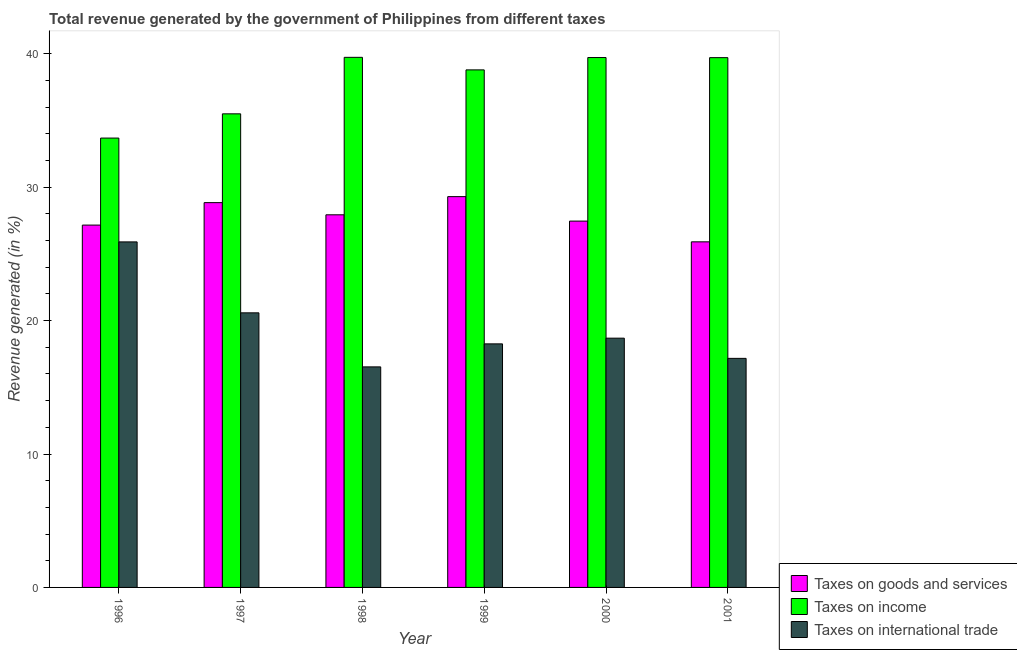How many groups of bars are there?
Your answer should be very brief. 6. Are the number of bars per tick equal to the number of legend labels?
Provide a succinct answer. Yes. Are the number of bars on each tick of the X-axis equal?
Give a very brief answer. Yes. How many bars are there on the 4th tick from the right?
Your response must be concise. 3. What is the percentage of revenue generated by taxes on income in 2001?
Offer a very short reply. 39.71. Across all years, what is the maximum percentage of revenue generated by taxes on income?
Your response must be concise. 39.74. Across all years, what is the minimum percentage of revenue generated by tax on international trade?
Give a very brief answer. 16.53. In which year was the percentage of revenue generated by taxes on goods and services maximum?
Your answer should be very brief. 1999. In which year was the percentage of revenue generated by tax on international trade minimum?
Provide a short and direct response. 1998. What is the total percentage of revenue generated by tax on international trade in the graph?
Offer a very short reply. 117.14. What is the difference between the percentage of revenue generated by tax on international trade in 1998 and that in 1999?
Offer a very short reply. -1.73. What is the difference between the percentage of revenue generated by tax on international trade in 1999 and the percentage of revenue generated by taxes on income in 2001?
Ensure brevity in your answer.  1.09. What is the average percentage of revenue generated by tax on international trade per year?
Make the answer very short. 19.52. In the year 1999, what is the difference between the percentage of revenue generated by tax on international trade and percentage of revenue generated by taxes on income?
Ensure brevity in your answer.  0. What is the ratio of the percentage of revenue generated by taxes on goods and services in 1999 to that in 2001?
Make the answer very short. 1.13. What is the difference between the highest and the second highest percentage of revenue generated by taxes on goods and services?
Your answer should be very brief. 0.45. What is the difference between the highest and the lowest percentage of revenue generated by taxes on income?
Your answer should be very brief. 6.05. Is the sum of the percentage of revenue generated by taxes on income in 1997 and 1998 greater than the maximum percentage of revenue generated by tax on international trade across all years?
Give a very brief answer. Yes. What does the 2nd bar from the left in 1998 represents?
Make the answer very short. Taxes on income. What does the 2nd bar from the right in 2000 represents?
Offer a terse response. Taxes on income. How many bars are there?
Provide a succinct answer. 18. How many years are there in the graph?
Your response must be concise. 6. Are the values on the major ticks of Y-axis written in scientific E-notation?
Offer a very short reply. No. Does the graph contain any zero values?
Make the answer very short. No. Where does the legend appear in the graph?
Give a very brief answer. Bottom right. What is the title of the graph?
Your answer should be compact. Total revenue generated by the government of Philippines from different taxes. What is the label or title of the Y-axis?
Offer a very short reply. Revenue generated (in %). What is the Revenue generated (in %) in Taxes on goods and services in 1996?
Offer a terse response. 27.16. What is the Revenue generated (in %) of Taxes on income in 1996?
Ensure brevity in your answer.  33.69. What is the Revenue generated (in %) in Taxes on international trade in 1996?
Offer a terse response. 25.9. What is the Revenue generated (in %) in Taxes on goods and services in 1997?
Your answer should be compact. 28.85. What is the Revenue generated (in %) of Taxes on income in 1997?
Offer a very short reply. 35.5. What is the Revenue generated (in %) in Taxes on international trade in 1997?
Your answer should be compact. 20.58. What is the Revenue generated (in %) of Taxes on goods and services in 1998?
Offer a very short reply. 27.93. What is the Revenue generated (in %) in Taxes on income in 1998?
Your answer should be compact. 39.74. What is the Revenue generated (in %) in Taxes on international trade in 1998?
Your response must be concise. 16.53. What is the Revenue generated (in %) of Taxes on goods and services in 1999?
Make the answer very short. 29.3. What is the Revenue generated (in %) in Taxes on income in 1999?
Your answer should be very brief. 38.8. What is the Revenue generated (in %) of Taxes on international trade in 1999?
Ensure brevity in your answer.  18.26. What is the Revenue generated (in %) in Taxes on goods and services in 2000?
Make the answer very short. 27.46. What is the Revenue generated (in %) of Taxes on income in 2000?
Offer a terse response. 39.72. What is the Revenue generated (in %) in Taxes on international trade in 2000?
Offer a very short reply. 18.69. What is the Revenue generated (in %) in Taxes on goods and services in 2001?
Keep it short and to the point. 25.91. What is the Revenue generated (in %) in Taxes on income in 2001?
Provide a succinct answer. 39.71. What is the Revenue generated (in %) of Taxes on international trade in 2001?
Your response must be concise. 17.17. Across all years, what is the maximum Revenue generated (in %) in Taxes on goods and services?
Offer a terse response. 29.3. Across all years, what is the maximum Revenue generated (in %) of Taxes on income?
Your response must be concise. 39.74. Across all years, what is the maximum Revenue generated (in %) of Taxes on international trade?
Provide a short and direct response. 25.9. Across all years, what is the minimum Revenue generated (in %) of Taxes on goods and services?
Offer a very short reply. 25.91. Across all years, what is the minimum Revenue generated (in %) of Taxes on income?
Your answer should be compact. 33.69. Across all years, what is the minimum Revenue generated (in %) in Taxes on international trade?
Offer a very short reply. 16.53. What is the total Revenue generated (in %) in Taxes on goods and services in the graph?
Give a very brief answer. 166.61. What is the total Revenue generated (in %) in Taxes on income in the graph?
Provide a succinct answer. 227.16. What is the total Revenue generated (in %) in Taxes on international trade in the graph?
Make the answer very short. 117.14. What is the difference between the Revenue generated (in %) in Taxes on goods and services in 1996 and that in 1997?
Your answer should be very brief. -1.68. What is the difference between the Revenue generated (in %) of Taxes on income in 1996 and that in 1997?
Offer a very short reply. -1.82. What is the difference between the Revenue generated (in %) of Taxes on international trade in 1996 and that in 1997?
Your answer should be very brief. 5.32. What is the difference between the Revenue generated (in %) of Taxes on goods and services in 1996 and that in 1998?
Your answer should be very brief. -0.77. What is the difference between the Revenue generated (in %) in Taxes on income in 1996 and that in 1998?
Your answer should be compact. -6.05. What is the difference between the Revenue generated (in %) of Taxes on international trade in 1996 and that in 1998?
Your response must be concise. 9.37. What is the difference between the Revenue generated (in %) of Taxes on goods and services in 1996 and that in 1999?
Give a very brief answer. -2.13. What is the difference between the Revenue generated (in %) of Taxes on income in 1996 and that in 1999?
Ensure brevity in your answer.  -5.11. What is the difference between the Revenue generated (in %) of Taxes on international trade in 1996 and that in 1999?
Provide a succinct answer. 7.64. What is the difference between the Revenue generated (in %) of Taxes on goods and services in 1996 and that in 2000?
Your answer should be compact. -0.3. What is the difference between the Revenue generated (in %) in Taxes on income in 1996 and that in 2000?
Ensure brevity in your answer.  -6.04. What is the difference between the Revenue generated (in %) in Taxes on international trade in 1996 and that in 2000?
Provide a short and direct response. 7.22. What is the difference between the Revenue generated (in %) of Taxes on goods and services in 1996 and that in 2001?
Give a very brief answer. 1.26. What is the difference between the Revenue generated (in %) in Taxes on income in 1996 and that in 2001?
Offer a terse response. -6.03. What is the difference between the Revenue generated (in %) in Taxes on international trade in 1996 and that in 2001?
Offer a very short reply. 8.73. What is the difference between the Revenue generated (in %) in Taxes on goods and services in 1997 and that in 1998?
Provide a short and direct response. 0.91. What is the difference between the Revenue generated (in %) of Taxes on income in 1997 and that in 1998?
Your answer should be compact. -4.24. What is the difference between the Revenue generated (in %) of Taxes on international trade in 1997 and that in 1998?
Offer a very short reply. 4.05. What is the difference between the Revenue generated (in %) in Taxes on goods and services in 1997 and that in 1999?
Your answer should be compact. -0.45. What is the difference between the Revenue generated (in %) in Taxes on income in 1997 and that in 1999?
Your answer should be compact. -3.29. What is the difference between the Revenue generated (in %) of Taxes on international trade in 1997 and that in 1999?
Provide a short and direct response. 2.33. What is the difference between the Revenue generated (in %) of Taxes on goods and services in 1997 and that in 2000?
Give a very brief answer. 1.38. What is the difference between the Revenue generated (in %) in Taxes on income in 1997 and that in 2000?
Your response must be concise. -4.22. What is the difference between the Revenue generated (in %) of Taxes on international trade in 1997 and that in 2000?
Your answer should be very brief. 1.9. What is the difference between the Revenue generated (in %) of Taxes on goods and services in 1997 and that in 2001?
Your answer should be compact. 2.94. What is the difference between the Revenue generated (in %) of Taxes on income in 1997 and that in 2001?
Your answer should be very brief. -4.21. What is the difference between the Revenue generated (in %) in Taxes on international trade in 1997 and that in 2001?
Your answer should be compact. 3.41. What is the difference between the Revenue generated (in %) in Taxes on goods and services in 1998 and that in 1999?
Make the answer very short. -1.36. What is the difference between the Revenue generated (in %) of Taxes on income in 1998 and that in 1999?
Provide a succinct answer. 0.94. What is the difference between the Revenue generated (in %) in Taxes on international trade in 1998 and that in 1999?
Give a very brief answer. -1.73. What is the difference between the Revenue generated (in %) of Taxes on goods and services in 1998 and that in 2000?
Your answer should be compact. 0.47. What is the difference between the Revenue generated (in %) of Taxes on income in 1998 and that in 2000?
Your answer should be compact. 0.02. What is the difference between the Revenue generated (in %) of Taxes on international trade in 1998 and that in 2000?
Your answer should be very brief. -2.15. What is the difference between the Revenue generated (in %) in Taxes on goods and services in 1998 and that in 2001?
Ensure brevity in your answer.  2.03. What is the difference between the Revenue generated (in %) in Taxes on income in 1998 and that in 2001?
Make the answer very short. 0.02. What is the difference between the Revenue generated (in %) in Taxes on international trade in 1998 and that in 2001?
Offer a very short reply. -0.64. What is the difference between the Revenue generated (in %) in Taxes on goods and services in 1999 and that in 2000?
Offer a terse response. 1.84. What is the difference between the Revenue generated (in %) of Taxes on income in 1999 and that in 2000?
Make the answer very short. -0.93. What is the difference between the Revenue generated (in %) in Taxes on international trade in 1999 and that in 2000?
Give a very brief answer. -0.43. What is the difference between the Revenue generated (in %) in Taxes on goods and services in 1999 and that in 2001?
Give a very brief answer. 3.39. What is the difference between the Revenue generated (in %) in Taxes on income in 1999 and that in 2001?
Your response must be concise. -0.92. What is the difference between the Revenue generated (in %) of Taxes on international trade in 1999 and that in 2001?
Offer a very short reply. 1.09. What is the difference between the Revenue generated (in %) in Taxes on goods and services in 2000 and that in 2001?
Keep it short and to the point. 1.55. What is the difference between the Revenue generated (in %) of Taxes on income in 2000 and that in 2001?
Your answer should be compact. 0.01. What is the difference between the Revenue generated (in %) of Taxes on international trade in 2000 and that in 2001?
Provide a short and direct response. 1.51. What is the difference between the Revenue generated (in %) in Taxes on goods and services in 1996 and the Revenue generated (in %) in Taxes on income in 1997?
Offer a very short reply. -8.34. What is the difference between the Revenue generated (in %) of Taxes on goods and services in 1996 and the Revenue generated (in %) of Taxes on international trade in 1997?
Make the answer very short. 6.58. What is the difference between the Revenue generated (in %) of Taxes on income in 1996 and the Revenue generated (in %) of Taxes on international trade in 1997?
Keep it short and to the point. 13.1. What is the difference between the Revenue generated (in %) in Taxes on goods and services in 1996 and the Revenue generated (in %) in Taxes on income in 1998?
Give a very brief answer. -12.58. What is the difference between the Revenue generated (in %) of Taxes on goods and services in 1996 and the Revenue generated (in %) of Taxes on international trade in 1998?
Keep it short and to the point. 10.63. What is the difference between the Revenue generated (in %) of Taxes on income in 1996 and the Revenue generated (in %) of Taxes on international trade in 1998?
Give a very brief answer. 17.15. What is the difference between the Revenue generated (in %) in Taxes on goods and services in 1996 and the Revenue generated (in %) in Taxes on income in 1999?
Ensure brevity in your answer.  -11.63. What is the difference between the Revenue generated (in %) in Taxes on goods and services in 1996 and the Revenue generated (in %) in Taxes on international trade in 1999?
Make the answer very short. 8.9. What is the difference between the Revenue generated (in %) in Taxes on income in 1996 and the Revenue generated (in %) in Taxes on international trade in 1999?
Give a very brief answer. 15.43. What is the difference between the Revenue generated (in %) of Taxes on goods and services in 1996 and the Revenue generated (in %) of Taxes on income in 2000?
Keep it short and to the point. -12.56. What is the difference between the Revenue generated (in %) of Taxes on goods and services in 1996 and the Revenue generated (in %) of Taxes on international trade in 2000?
Your answer should be compact. 8.48. What is the difference between the Revenue generated (in %) of Taxes on income in 1996 and the Revenue generated (in %) of Taxes on international trade in 2000?
Your response must be concise. 15. What is the difference between the Revenue generated (in %) of Taxes on goods and services in 1996 and the Revenue generated (in %) of Taxes on income in 2001?
Your answer should be compact. -12.55. What is the difference between the Revenue generated (in %) in Taxes on goods and services in 1996 and the Revenue generated (in %) in Taxes on international trade in 2001?
Provide a succinct answer. 9.99. What is the difference between the Revenue generated (in %) of Taxes on income in 1996 and the Revenue generated (in %) of Taxes on international trade in 2001?
Provide a short and direct response. 16.51. What is the difference between the Revenue generated (in %) in Taxes on goods and services in 1997 and the Revenue generated (in %) in Taxes on income in 1998?
Ensure brevity in your answer.  -10.89. What is the difference between the Revenue generated (in %) in Taxes on goods and services in 1997 and the Revenue generated (in %) in Taxes on international trade in 1998?
Provide a succinct answer. 12.31. What is the difference between the Revenue generated (in %) in Taxes on income in 1997 and the Revenue generated (in %) in Taxes on international trade in 1998?
Offer a terse response. 18.97. What is the difference between the Revenue generated (in %) of Taxes on goods and services in 1997 and the Revenue generated (in %) of Taxes on income in 1999?
Your response must be concise. -9.95. What is the difference between the Revenue generated (in %) of Taxes on goods and services in 1997 and the Revenue generated (in %) of Taxes on international trade in 1999?
Make the answer very short. 10.59. What is the difference between the Revenue generated (in %) in Taxes on income in 1997 and the Revenue generated (in %) in Taxes on international trade in 1999?
Offer a terse response. 17.24. What is the difference between the Revenue generated (in %) of Taxes on goods and services in 1997 and the Revenue generated (in %) of Taxes on income in 2000?
Give a very brief answer. -10.88. What is the difference between the Revenue generated (in %) of Taxes on goods and services in 1997 and the Revenue generated (in %) of Taxes on international trade in 2000?
Make the answer very short. 10.16. What is the difference between the Revenue generated (in %) in Taxes on income in 1997 and the Revenue generated (in %) in Taxes on international trade in 2000?
Your answer should be compact. 16.82. What is the difference between the Revenue generated (in %) in Taxes on goods and services in 1997 and the Revenue generated (in %) in Taxes on income in 2001?
Your response must be concise. -10.87. What is the difference between the Revenue generated (in %) of Taxes on goods and services in 1997 and the Revenue generated (in %) of Taxes on international trade in 2001?
Keep it short and to the point. 11.67. What is the difference between the Revenue generated (in %) in Taxes on income in 1997 and the Revenue generated (in %) in Taxes on international trade in 2001?
Your answer should be very brief. 18.33. What is the difference between the Revenue generated (in %) of Taxes on goods and services in 1998 and the Revenue generated (in %) of Taxes on income in 1999?
Provide a succinct answer. -10.86. What is the difference between the Revenue generated (in %) of Taxes on goods and services in 1998 and the Revenue generated (in %) of Taxes on international trade in 1999?
Keep it short and to the point. 9.67. What is the difference between the Revenue generated (in %) in Taxes on income in 1998 and the Revenue generated (in %) in Taxes on international trade in 1999?
Your answer should be compact. 21.48. What is the difference between the Revenue generated (in %) of Taxes on goods and services in 1998 and the Revenue generated (in %) of Taxes on income in 2000?
Your answer should be compact. -11.79. What is the difference between the Revenue generated (in %) in Taxes on goods and services in 1998 and the Revenue generated (in %) in Taxes on international trade in 2000?
Give a very brief answer. 9.25. What is the difference between the Revenue generated (in %) of Taxes on income in 1998 and the Revenue generated (in %) of Taxes on international trade in 2000?
Your answer should be compact. 21.05. What is the difference between the Revenue generated (in %) of Taxes on goods and services in 1998 and the Revenue generated (in %) of Taxes on income in 2001?
Provide a succinct answer. -11.78. What is the difference between the Revenue generated (in %) of Taxes on goods and services in 1998 and the Revenue generated (in %) of Taxes on international trade in 2001?
Offer a terse response. 10.76. What is the difference between the Revenue generated (in %) of Taxes on income in 1998 and the Revenue generated (in %) of Taxes on international trade in 2001?
Your answer should be very brief. 22.57. What is the difference between the Revenue generated (in %) in Taxes on goods and services in 1999 and the Revenue generated (in %) in Taxes on income in 2000?
Provide a short and direct response. -10.43. What is the difference between the Revenue generated (in %) in Taxes on goods and services in 1999 and the Revenue generated (in %) in Taxes on international trade in 2000?
Provide a succinct answer. 10.61. What is the difference between the Revenue generated (in %) in Taxes on income in 1999 and the Revenue generated (in %) in Taxes on international trade in 2000?
Ensure brevity in your answer.  20.11. What is the difference between the Revenue generated (in %) in Taxes on goods and services in 1999 and the Revenue generated (in %) in Taxes on income in 2001?
Offer a terse response. -10.42. What is the difference between the Revenue generated (in %) of Taxes on goods and services in 1999 and the Revenue generated (in %) of Taxes on international trade in 2001?
Your answer should be very brief. 12.12. What is the difference between the Revenue generated (in %) in Taxes on income in 1999 and the Revenue generated (in %) in Taxes on international trade in 2001?
Give a very brief answer. 21.63. What is the difference between the Revenue generated (in %) in Taxes on goods and services in 2000 and the Revenue generated (in %) in Taxes on income in 2001?
Your answer should be very brief. -12.25. What is the difference between the Revenue generated (in %) in Taxes on goods and services in 2000 and the Revenue generated (in %) in Taxes on international trade in 2001?
Keep it short and to the point. 10.29. What is the difference between the Revenue generated (in %) in Taxes on income in 2000 and the Revenue generated (in %) in Taxes on international trade in 2001?
Give a very brief answer. 22.55. What is the average Revenue generated (in %) of Taxes on goods and services per year?
Ensure brevity in your answer.  27.77. What is the average Revenue generated (in %) of Taxes on income per year?
Provide a succinct answer. 37.86. What is the average Revenue generated (in %) in Taxes on international trade per year?
Your answer should be very brief. 19.52. In the year 1996, what is the difference between the Revenue generated (in %) of Taxes on goods and services and Revenue generated (in %) of Taxes on income?
Your answer should be very brief. -6.52. In the year 1996, what is the difference between the Revenue generated (in %) in Taxes on goods and services and Revenue generated (in %) in Taxes on international trade?
Your response must be concise. 1.26. In the year 1996, what is the difference between the Revenue generated (in %) in Taxes on income and Revenue generated (in %) in Taxes on international trade?
Offer a very short reply. 7.78. In the year 1997, what is the difference between the Revenue generated (in %) in Taxes on goods and services and Revenue generated (in %) in Taxes on income?
Ensure brevity in your answer.  -6.66. In the year 1997, what is the difference between the Revenue generated (in %) in Taxes on goods and services and Revenue generated (in %) in Taxes on international trade?
Provide a short and direct response. 8.26. In the year 1997, what is the difference between the Revenue generated (in %) in Taxes on income and Revenue generated (in %) in Taxes on international trade?
Keep it short and to the point. 14.92. In the year 1998, what is the difference between the Revenue generated (in %) of Taxes on goods and services and Revenue generated (in %) of Taxes on income?
Ensure brevity in your answer.  -11.81. In the year 1998, what is the difference between the Revenue generated (in %) in Taxes on goods and services and Revenue generated (in %) in Taxes on international trade?
Your response must be concise. 11.4. In the year 1998, what is the difference between the Revenue generated (in %) in Taxes on income and Revenue generated (in %) in Taxes on international trade?
Ensure brevity in your answer.  23.21. In the year 1999, what is the difference between the Revenue generated (in %) in Taxes on goods and services and Revenue generated (in %) in Taxes on income?
Your response must be concise. -9.5. In the year 1999, what is the difference between the Revenue generated (in %) in Taxes on goods and services and Revenue generated (in %) in Taxes on international trade?
Offer a terse response. 11.04. In the year 1999, what is the difference between the Revenue generated (in %) in Taxes on income and Revenue generated (in %) in Taxes on international trade?
Provide a short and direct response. 20.54. In the year 2000, what is the difference between the Revenue generated (in %) of Taxes on goods and services and Revenue generated (in %) of Taxes on income?
Provide a short and direct response. -12.26. In the year 2000, what is the difference between the Revenue generated (in %) of Taxes on goods and services and Revenue generated (in %) of Taxes on international trade?
Provide a short and direct response. 8.78. In the year 2000, what is the difference between the Revenue generated (in %) in Taxes on income and Revenue generated (in %) in Taxes on international trade?
Provide a short and direct response. 21.04. In the year 2001, what is the difference between the Revenue generated (in %) of Taxes on goods and services and Revenue generated (in %) of Taxes on income?
Provide a short and direct response. -13.81. In the year 2001, what is the difference between the Revenue generated (in %) of Taxes on goods and services and Revenue generated (in %) of Taxes on international trade?
Your answer should be compact. 8.74. In the year 2001, what is the difference between the Revenue generated (in %) in Taxes on income and Revenue generated (in %) in Taxes on international trade?
Offer a terse response. 22.54. What is the ratio of the Revenue generated (in %) in Taxes on goods and services in 1996 to that in 1997?
Offer a very short reply. 0.94. What is the ratio of the Revenue generated (in %) of Taxes on income in 1996 to that in 1997?
Make the answer very short. 0.95. What is the ratio of the Revenue generated (in %) in Taxes on international trade in 1996 to that in 1997?
Your response must be concise. 1.26. What is the ratio of the Revenue generated (in %) in Taxes on goods and services in 1996 to that in 1998?
Ensure brevity in your answer.  0.97. What is the ratio of the Revenue generated (in %) in Taxes on income in 1996 to that in 1998?
Provide a succinct answer. 0.85. What is the ratio of the Revenue generated (in %) in Taxes on international trade in 1996 to that in 1998?
Your response must be concise. 1.57. What is the ratio of the Revenue generated (in %) of Taxes on goods and services in 1996 to that in 1999?
Offer a very short reply. 0.93. What is the ratio of the Revenue generated (in %) of Taxes on income in 1996 to that in 1999?
Make the answer very short. 0.87. What is the ratio of the Revenue generated (in %) in Taxes on international trade in 1996 to that in 1999?
Provide a short and direct response. 1.42. What is the ratio of the Revenue generated (in %) in Taxes on goods and services in 1996 to that in 2000?
Make the answer very short. 0.99. What is the ratio of the Revenue generated (in %) in Taxes on income in 1996 to that in 2000?
Your response must be concise. 0.85. What is the ratio of the Revenue generated (in %) of Taxes on international trade in 1996 to that in 2000?
Provide a succinct answer. 1.39. What is the ratio of the Revenue generated (in %) in Taxes on goods and services in 1996 to that in 2001?
Your response must be concise. 1.05. What is the ratio of the Revenue generated (in %) of Taxes on income in 1996 to that in 2001?
Keep it short and to the point. 0.85. What is the ratio of the Revenue generated (in %) of Taxes on international trade in 1996 to that in 2001?
Your answer should be very brief. 1.51. What is the ratio of the Revenue generated (in %) in Taxes on goods and services in 1997 to that in 1998?
Ensure brevity in your answer.  1.03. What is the ratio of the Revenue generated (in %) of Taxes on income in 1997 to that in 1998?
Ensure brevity in your answer.  0.89. What is the ratio of the Revenue generated (in %) in Taxes on international trade in 1997 to that in 1998?
Your answer should be compact. 1.25. What is the ratio of the Revenue generated (in %) of Taxes on goods and services in 1997 to that in 1999?
Ensure brevity in your answer.  0.98. What is the ratio of the Revenue generated (in %) in Taxes on income in 1997 to that in 1999?
Offer a terse response. 0.92. What is the ratio of the Revenue generated (in %) of Taxes on international trade in 1997 to that in 1999?
Your answer should be compact. 1.13. What is the ratio of the Revenue generated (in %) in Taxes on goods and services in 1997 to that in 2000?
Offer a very short reply. 1.05. What is the ratio of the Revenue generated (in %) of Taxes on income in 1997 to that in 2000?
Ensure brevity in your answer.  0.89. What is the ratio of the Revenue generated (in %) of Taxes on international trade in 1997 to that in 2000?
Offer a very short reply. 1.1. What is the ratio of the Revenue generated (in %) of Taxes on goods and services in 1997 to that in 2001?
Offer a terse response. 1.11. What is the ratio of the Revenue generated (in %) in Taxes on income in 1997 to that in 2001?
Keep it short and to the point. 0.89. What is the ratio of the Revenue generated (in %) in Taxes on international trade in 1997 to that in 2001?
Make the answer very short. 1.2. What is the ratio of the Revenue generated (in %) in Taxes on goods and services in 1998 to that in 1999?
Your response must be concise. 0.95. What is the ratio of the Revenue generated (in %) of Taxes on income in 1998 to that in 1999?
Offer a very short reply. 1.02. What is the ratio of the Revenue generated (in %) in Taxes on international trade in 1998 to that in 1999?
Ensure brevity in your answer.  0.91. What is the ratio of the Revenue generated (in %) in Taxes on goods and services in 1998 to that in 2000?
Your answer should be very brief. 1.02. What is the ratio of the Revenue generated (in %) in Taxes on income in 1998 to that in 2000?
Provide a succinct answer. 1. What is the ratio of the Revenue generated (in %) in Taxes on international trade in 1998 to that in 2000?
Offer a very short reply. 0.88. What is the ratio of the Revenue generated (in %) in Taxes on goods and services in 1998 to that in 2001?
Provide a succinct answer. 1.08. What is the ratio of the Revenue generated (in %) in Taxes on income in 1998 to that in 2001?
Provide a succinct answer. 1. What is the ratio of the Revenue generated (in %) in Taxes on international trade in 1998 to that in 2001?
Keep it short and to the point. 0.96. What is the ratio of the Revenue generated (in %) of Taxes on goods and services in 1999 to that in 2000?
Provide a succinct answer. 1.07. What is the ratio of the Revenue generated (in %) in Taxes on income in 1999 to that in 2000?
Your response must be concise. 0.98. What is the ratio of the Revenue generated (in %) of Taxes on international trade in 1999 to that in 2000?
Offer a terse response. 0.98. What is the ratio of the Revenue generated (in %) of Taxes on goods and services in 1999 to that in 2001?
Provide a succinct answer. 1.13. What is the ratio of the Revenue generated (in %) of Taxes on income in 1999 to that in 2001?
Your answer should be compact. 0.98. What is the ratio of the Revenue generated (in %) in Taxes on international trade in 1999 to that in 2001?
Give a very brief answer. 1.06. What is the ratio of the Revenue generated (in %) in Taxes on goods and services in 2000 to that in 2001?
Offer a terse response. 1.06. What is the ratio of the Revenue generated (in %) in Taxes on income in 2000 to that in 2001?
Give a very brief answer. 1. What is the ratio of the Revenue generated (in %) of Taxes on international trade in 2000 to that in 2001?
Your answer should be compact. 1.09. What is the difference between the highest and the second highest Revenue generated (in %) of Taxes on goods and services?
Give a very brief answer. 0.45. What is the difference between the highest and the second highest Revenue generated (in %) of Taxes on income?
Ensure brevity in your answer.  0.02. What is the difference between the highest and the second highest Revenue generated (in %) in Taxes on international trade?
Your response must be concise. 5.32. What is the difference between the highest and the lowest Revenue generated (in %) of Taxes on goods and services?
Your answer should be compact. 3.39. What is the difference between the highest and the lowest Revenue generated (in %) of Taxes on income?
Offer a very short reply. 6.05. What is the difference between the highest and the lowest Revenue generated (in %) in Taxes on international trade?
Provide a short and direct response. 9.37. 